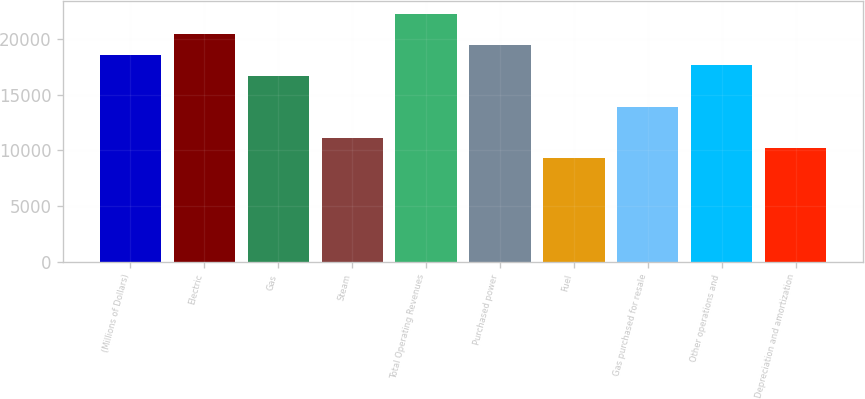Convert chart. <chart><loc_0><loc_0><loc_500><loc_500><bar_chart><fcel>(Millions of Dollars)<fcel>Electric<fcel>Gas<fcel>Steam<fcel>Total Operating Revenues<fcel>Purchased power<fcel>Fuel<fcel>Gas purchased for resale<fcel>Other operations and<fcel>Depreciation and amortization<nl><fcel>18571<fcel>20427.6<fcel>16714.4<fcel>11144.6<fcel>22284.2<fcel>19499.3<fcel>9288<fcel>13929.5<fcel>17642.7<fcel>10216.3<nl></chart> 